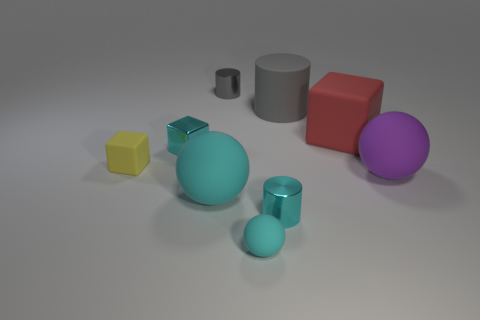Subtract all cyan matte balls. How many balls are left? 1 Subtract all cyan cylinders. How many cylinders are left? 2 Add 1 big cyan balls. How many objects exist? 10 Subtract 2 blocks. How many blocks are left? 1 Add 6 tiny purple rubber blocks. How many tiny purple rubber blocks exist? 6 Subtract 0 yellow cylinders. How many objects are left? 9 Subtract all blocks. How many objects are left? 6 Subtract all cyan cylinders. Subtract all red balls. How many cylinders are left? 2 Subtract all brown cubes. How many cyan spheres are left? 2 Subtract all tiny blue things. Subtract all rubber objects. How many objects are left? 3 